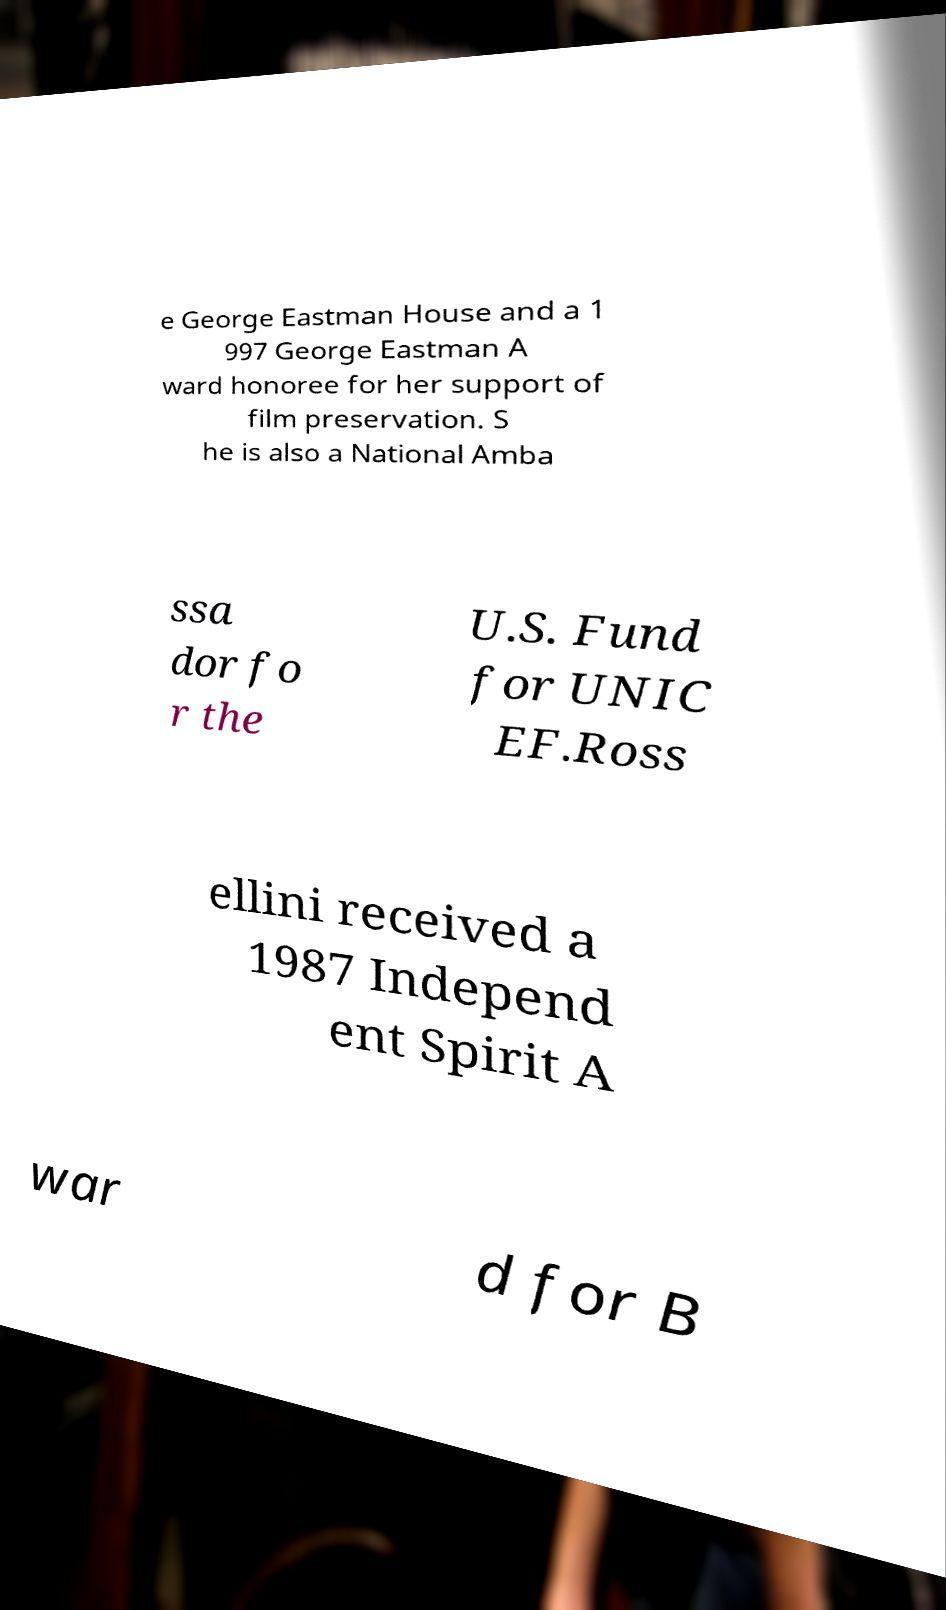There's text embedded in this image that I need extracted. Can you transcribe it verbatim? e George Eastman House and a 1 997 George Eastman A ward honoree for her support of film preservation. S he is also a National Amba ssa dor fo r the U.S. Fund for UNIC EF.Ross ellini received a 1987 Independ ent Spirit A war d for B 